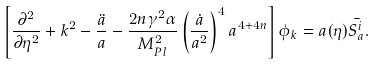Convert formula to latex. <formula><loc_0><loc_0><loc_500><loc_500>\left [ \frac { \partial ^ { 2 } } { \partial \eta ^ { 2 } } + k ^ { 2 } - \frac { \ddot { a } } { a } - \frac { 2 n \gamma ^ { 2 } \alpha } { M ^ { 2 } _ { P l } } \left ( \frac { \dot { a } } { a ^ { 2 } } \right ) ^ { 4 } a ^ { 4 + 4 n } \right ] \phi _ { k } = a ( \eta ) \bar { S ^ { i } _ { a } } .</formula> 